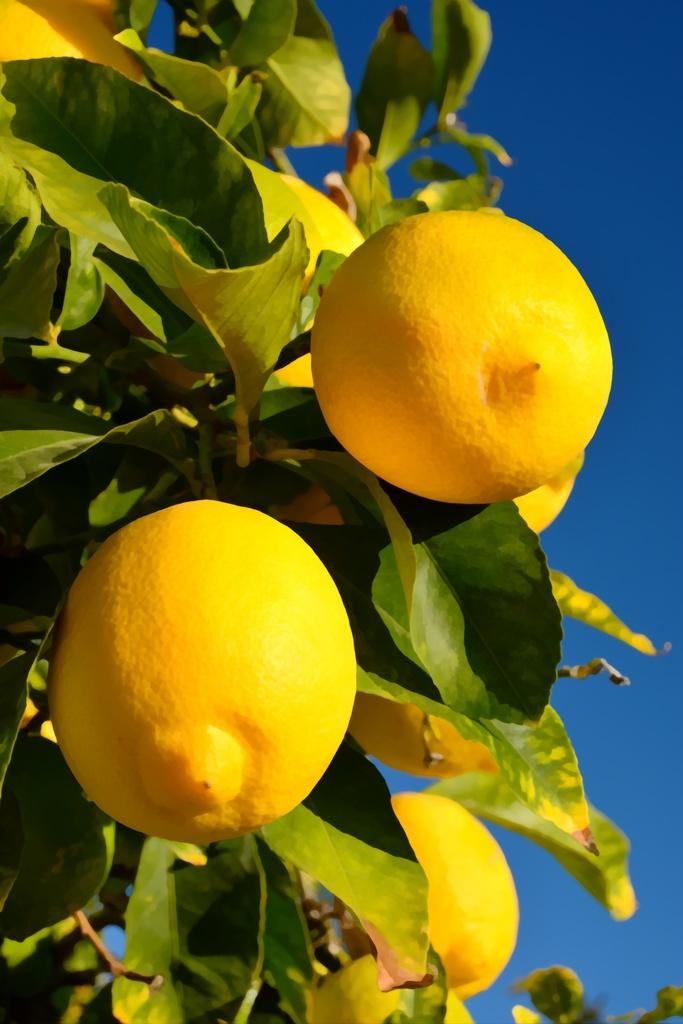What type of fruits can be seen on the plant in the image? There are yellow color fruits on a plant in the image. What can be seen in the background of the image? The sky is visible in the background of the image. What type of yarn is being used by the secretary in the image? There is no secretary or yarn present in the image. 